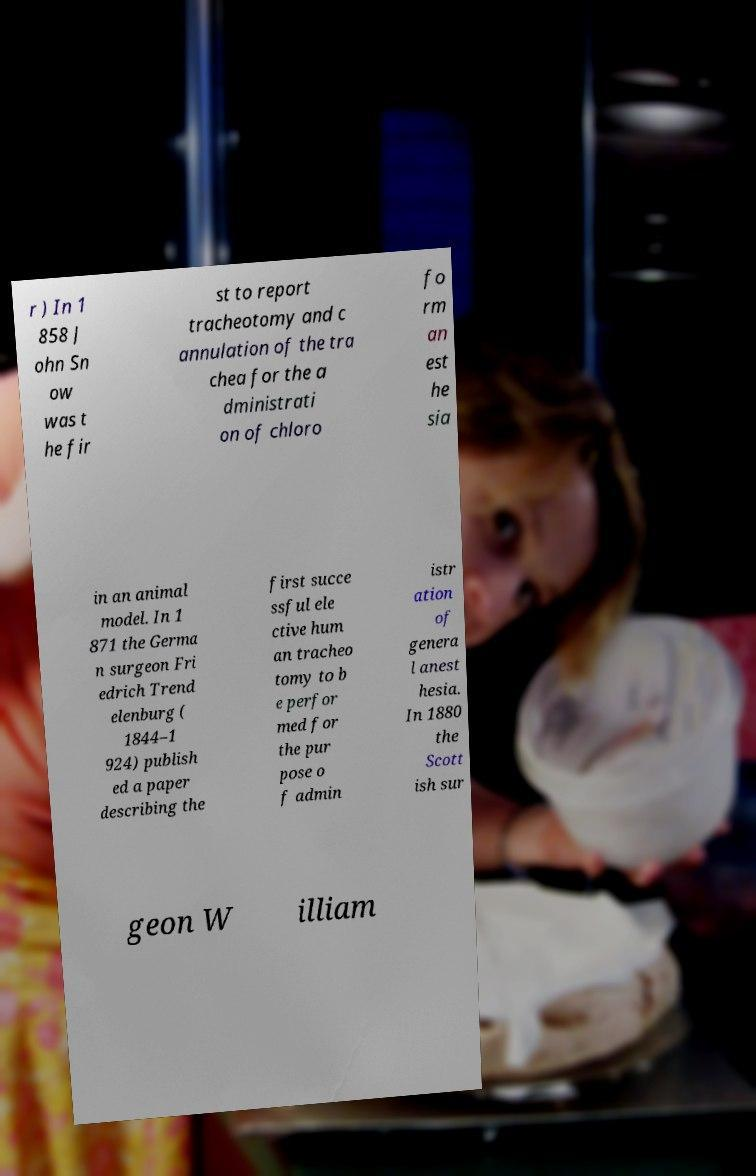Could you assist in decoding the text presented in this image and type it out clearly? r ) In 1 858 J ohn Sn ow was t he fir st to report tracheotomy and c annulation of the tra chea for the a dministrati on of chloro fo rm an est he sia in an animal model. In 1 871 the Germa n surgeon Fri edrich Trend elenburg ( 1844–1 924) publish ed a paper describing the first succe ssful ele ctive hum an tracheo tomy to b e perfor med for the pur pose o f admin istr ation of genera l anest hesia. In 1880 the Scott ish sur geon W illiam 